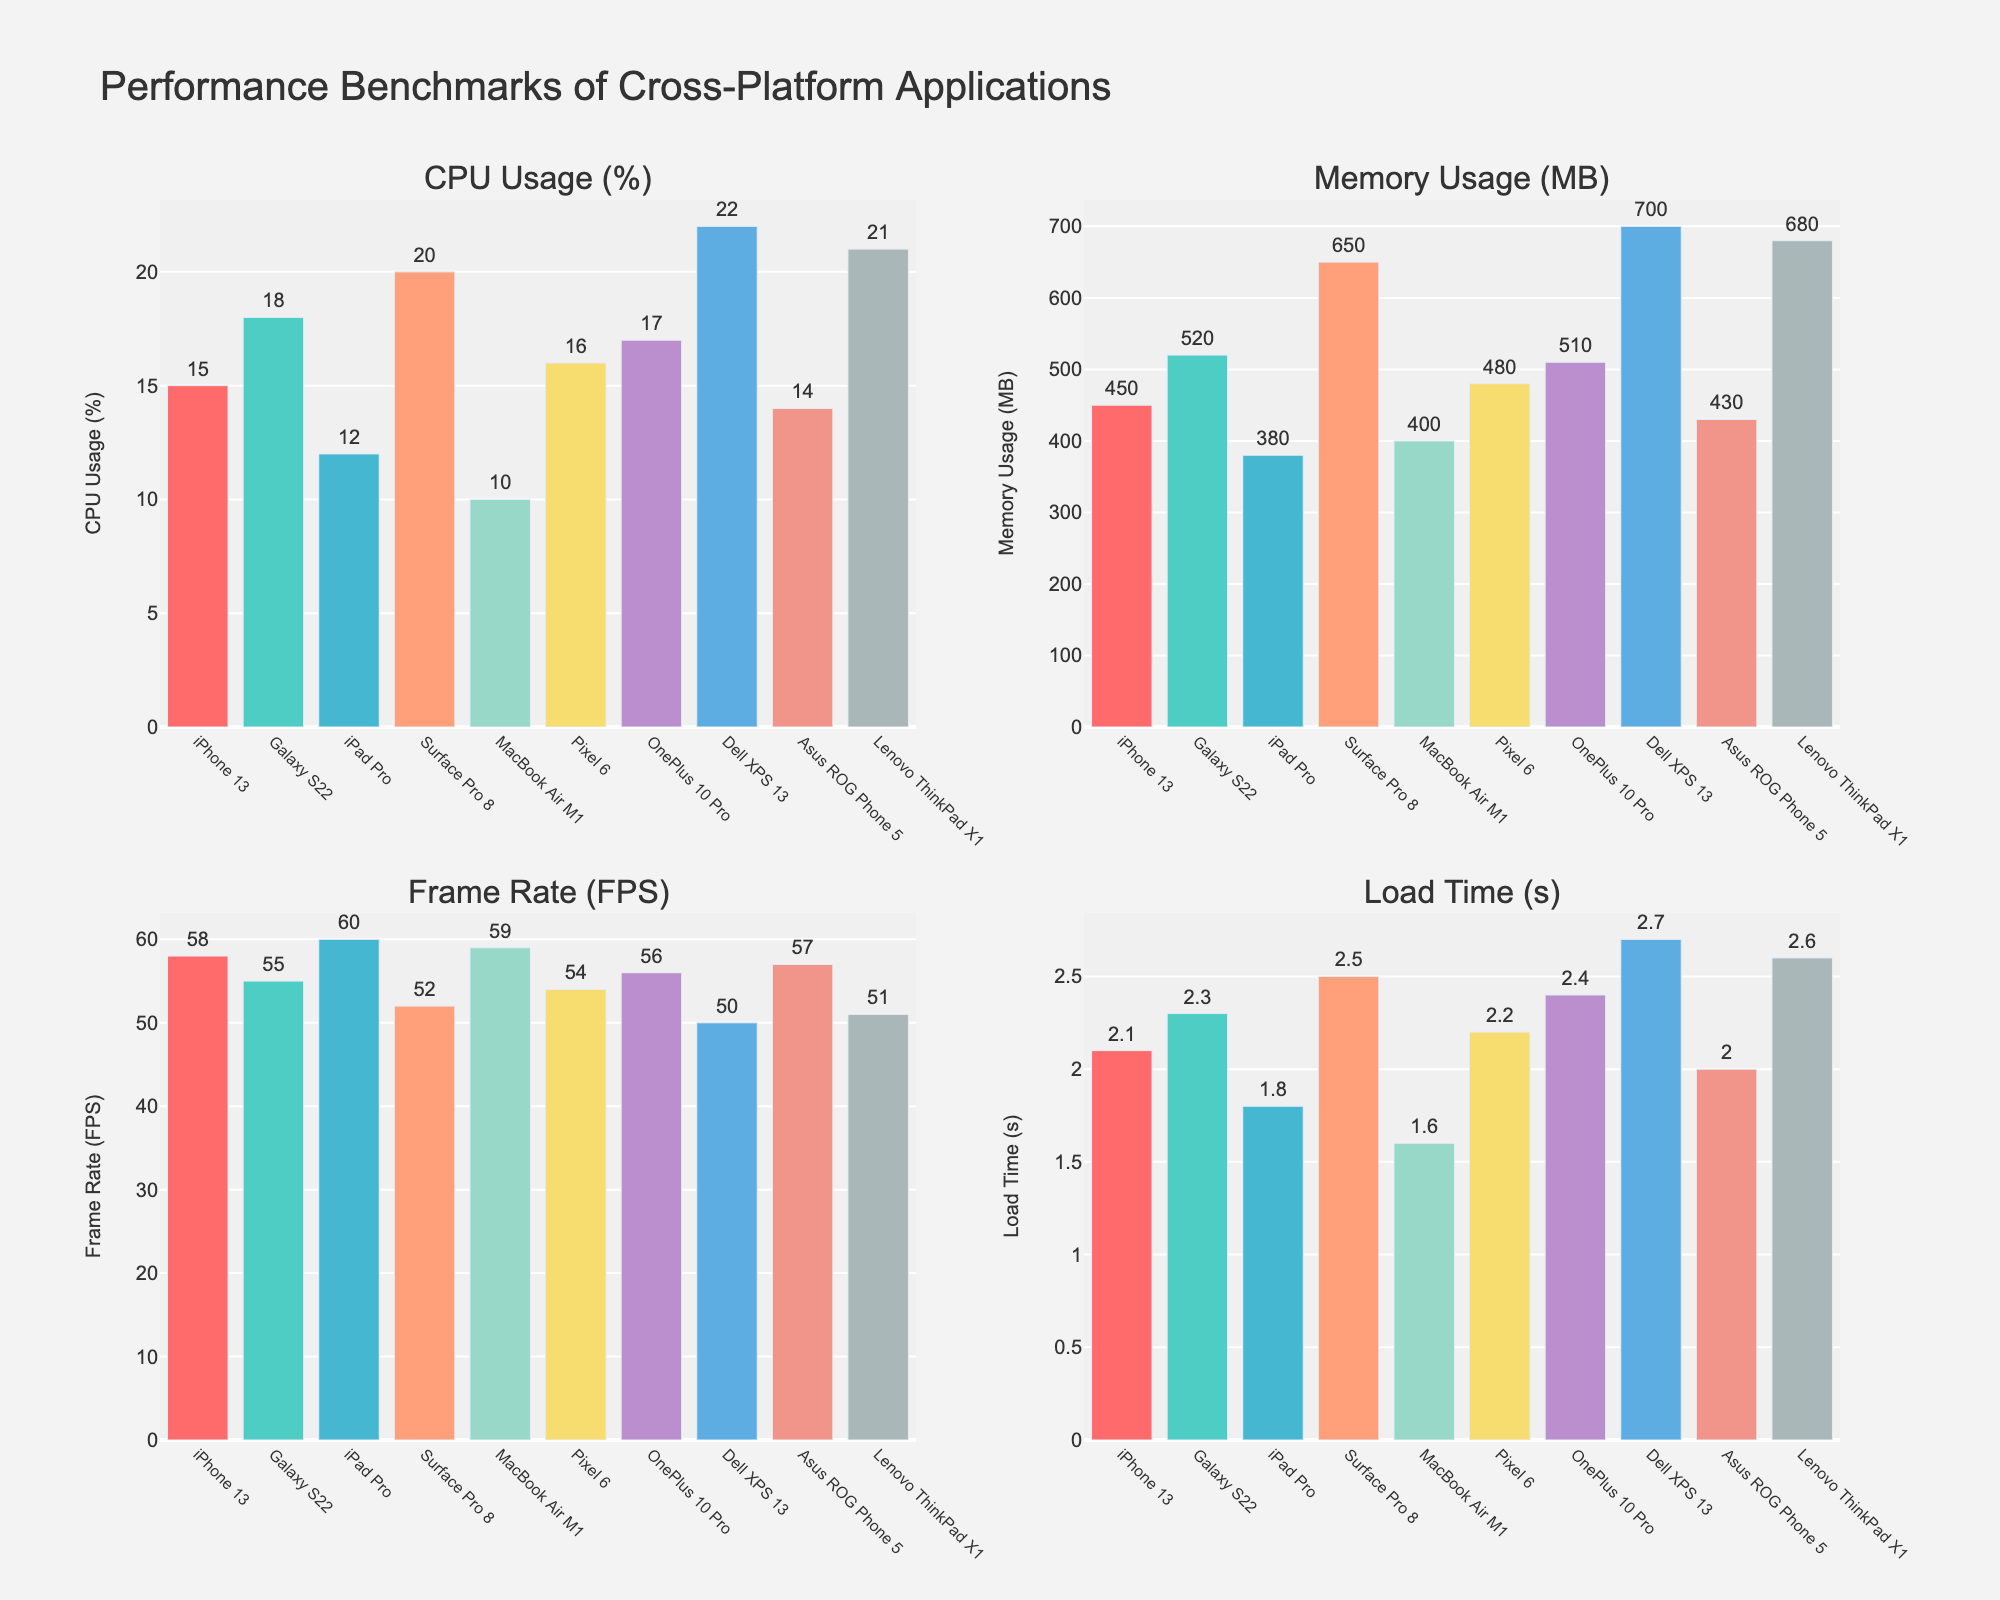Which device has the highest CPU usage? The subplot for CPU usage shows bars for each device. The tallest bar represents "Dell XPS 13" with a value of 22%.
Answer: Dell XPS 13 Which device exhibits the lowest memory usage? The subplot for Memory Usage shows bars for each device, where "iPad Pro" has the smallest bar with a memory usage of 380 MB.
Answer: iPad Pro Which devices have a frame rate of above 56 FPS? By looking at the Frame Rate subplot, devices with bars extending beyond 56 FPS are "iPhone 13," "iPad Pro," "MacBook Air M1," and "Asus ROG Phone 5".
Answer: iPhone 13, iPad Pro, MacBook Air M1, Asus ROG Phone 5 What is the median value of CPU usage across all devices? The CPU usage values for all devices in ascending order are: 10, 12, 14, 15, 16, 17, 18, 20, 21, 22. The median value (middle value in an ordered list) will be the average of the 5th and 6th values: (16 + 17)/2 = 16.5.
Answer: 16.5 What is the sum of load times for the devices "Galaxy S22" and "Surface Pro 8"? According to the Load Time subplot, the load times are: "Galaxy S22" = 2.3s and "Surface Pro 8" = 2.5s. Summing these gives 2.3 + 2.5 = 4.8s.
Answer: 4.8s Which device has the highest frame rate, and what is that value? The subplot for Frame Rate shows that "iPad Pro" has the highest bar with a frame rate of 60 FPS.
Answer: iPad Pro, 60 FPS Compare the memory usage of "Galaxy S22" and "MacBook Air M1". Which device uses more memory and by how much? The Memory Usage subplot shows "Galaxy S22" with 520 MB and "MacBook Air M1" with 400 MB. The difference is 520 - 400 = 120 MB. Therefore, "Galaxy S22" uses more memory by 120 MB.
Answer: Galaxy S22, 120 MB On which device does the application load the fastest? The Load Time subplot shows that "MacBook Air M1" has the shortest bar with a load time of 1.6s, making it the fastest.
Answer: MacBook Air M1 What is the average memory usage across all devices? Add all memory usage values and divide by the number of devices: (450 + 520 + 380 + 650 + 400 + 480 + 510 + 700 + 430 + 680) / 10 = 520 MB.
Answer: 520 MB 